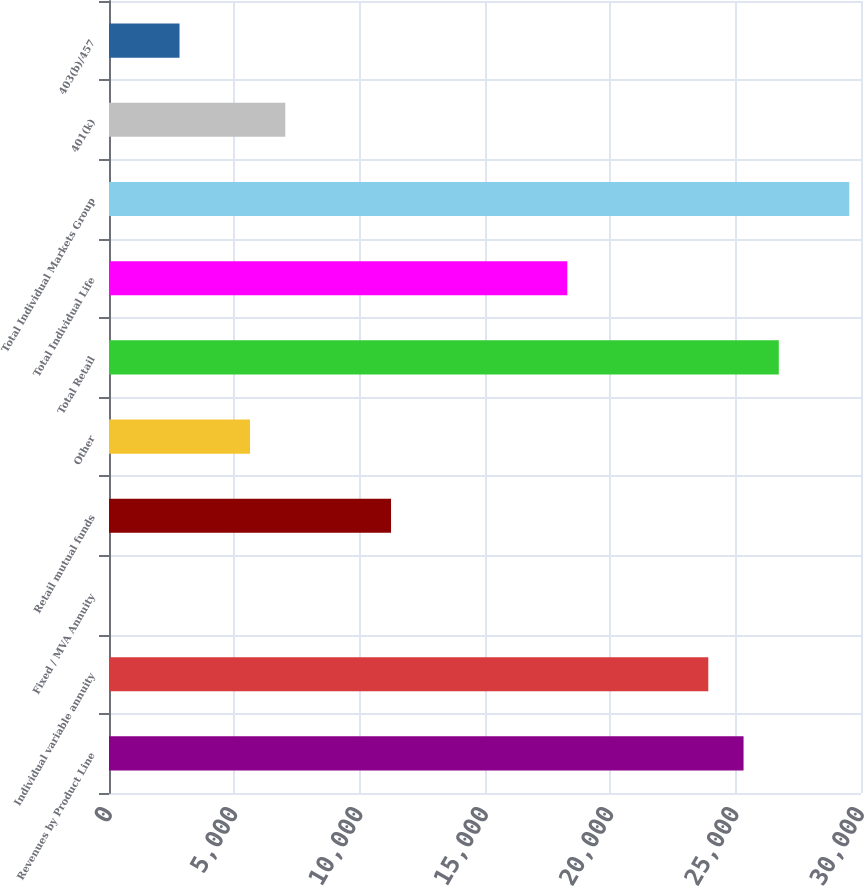Convert chart. <chart><loc_0><loc_0><loc_500><loc_500><bar_chart><fcel>Revenues by Product Line<fcel>Individual variable annuity<fcel>Fixed / MVA Annuity<fcel>Retail mutual funds<fcel>Other<fcel>Total Retail<fcel>Total Individual Life<fcel>Total Individual Markets Group<fcel>401(k)<fcel>403(b)/457<nl><fcel>25314.4<fcel>23908.1<fcel>1<fcel>11251.4<fcel>5626.2<fcel>26720.7<fcel>18282.9<fcel>29533.3<fcel>7032.5<fcel>2813.6<nl></chart> 